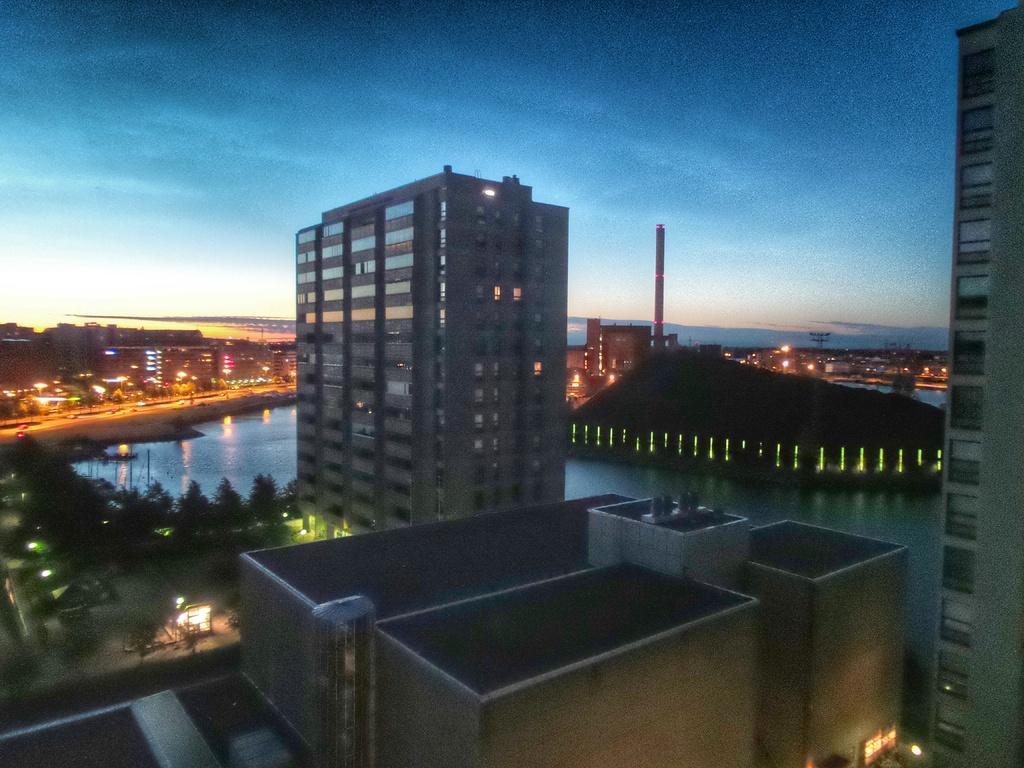How would you summarize this image in a sentence or two? In the image I can see buildings, trees, lights, street lights, the water and some other objects. In the background I can see the sky. 